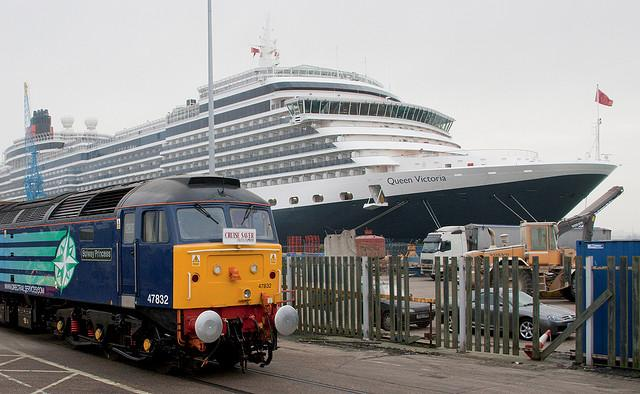The train is parked near what type of body of water?

Choices:
A) sea
B) lake
C) marsh
D) river sea 